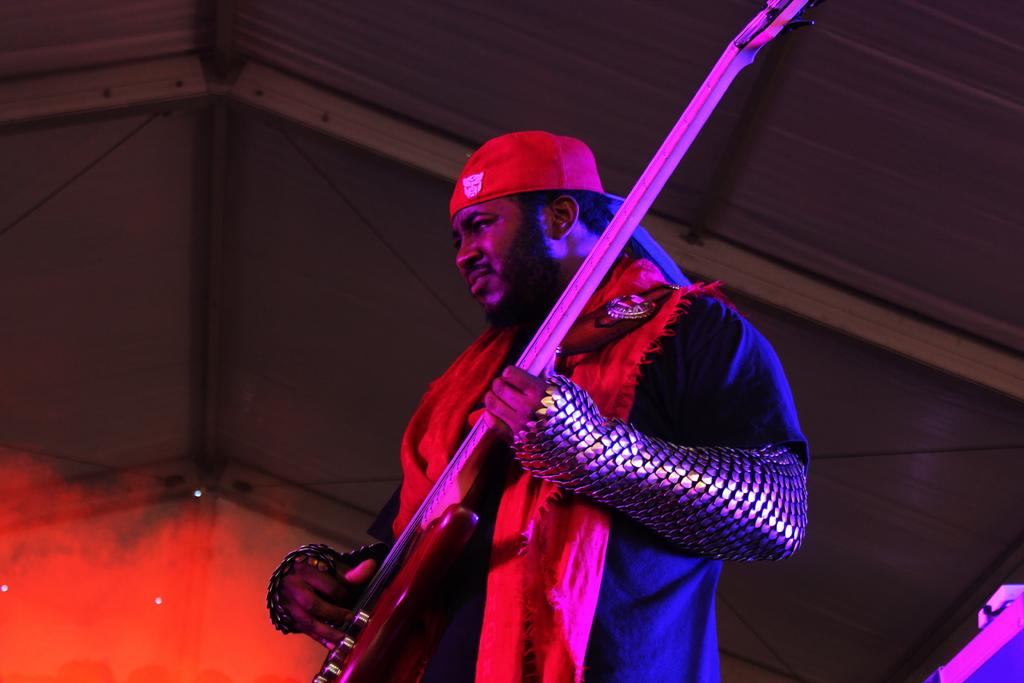What is the main subject of the image? There is a person in the image. What is the person holding in the image? The person is holding a guitar. What can be seen in the background of the image? There is a roof in the background of the image. How many spiders are crawling on the guitar in the image? There are no spiders present in the image, and therefore no such activity can be observed. 